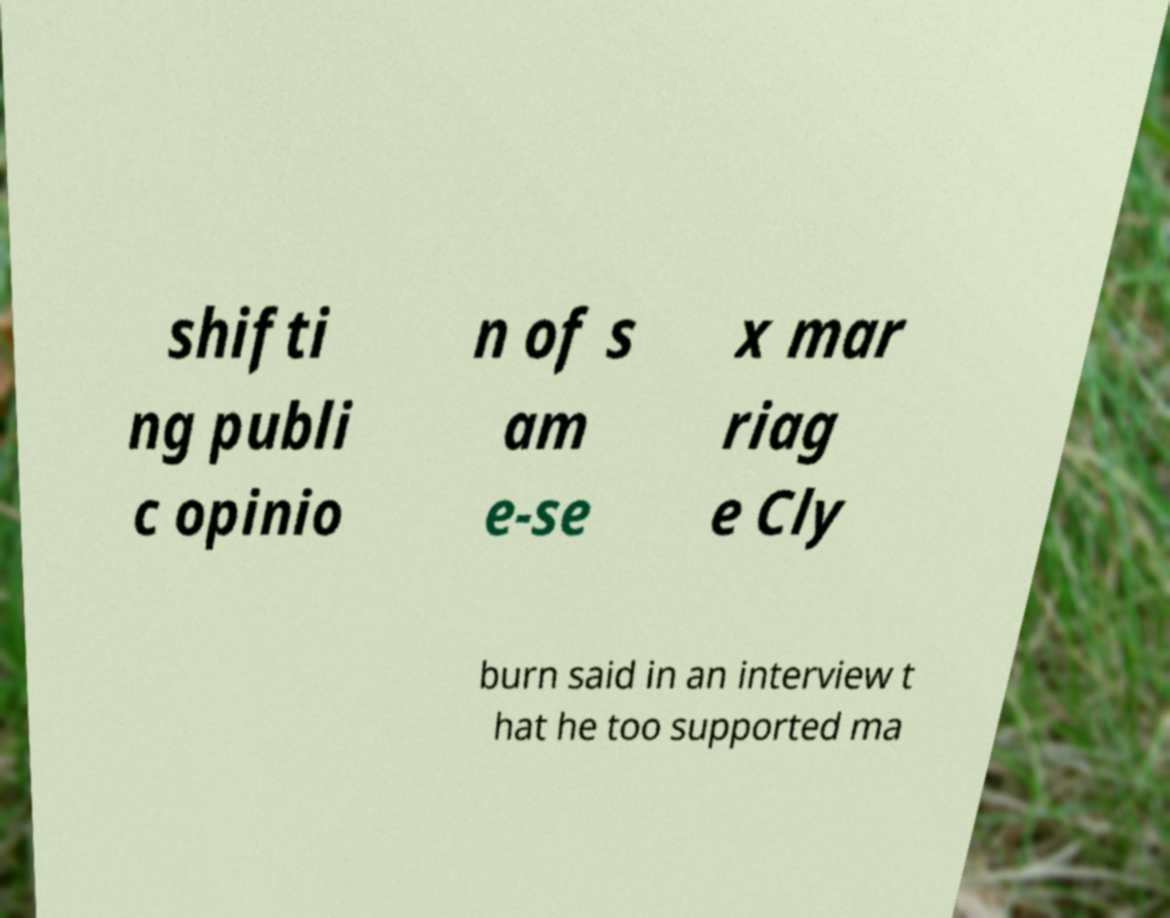For documentation purposes, I need the text within this image transcribed. Could you provide that? shifti ng publi c opinio n of s am e-se x mar riag e Cly burn said in an interview t hat he too supported ma 